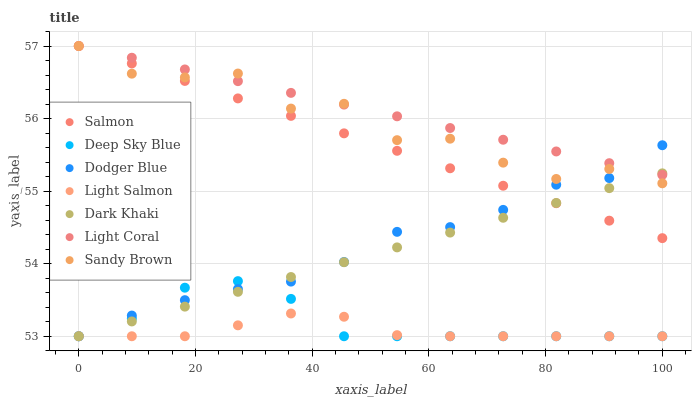Does Light Salmon have the minimum area under the curve?
Answer yes or no. Yes. Does Light Coral have the maximum area under the curve?
Answer yes or no. Yes. Does Salmon have the minimum area under the curve?
Answer yes or no. No. Does Salmon have the maximum area under the curve?
Answer yes or no. No. Is Salmon the smoothest?
Answer yes or no. Yes. Is Sandy Brown the roughest?
Answer yes or no. Yes. Is Light Salmon the smoothest?
Answer yes or no. No. Is Light Salmon the roughest?
Answer yes or no. No. Does Light Salmon have the lowest value?
Answer yes or no. Yes. Does Salmon have the lowest value?
Answer yes or no. No. Does Sandy Brown have the highest value?
Answer yes or no. Yes. Does Light Salmon have the highest value?
Answer yes or no. No. Is Deep Sky Blue less than Salmon?
Answer yes or no. Yes. Is Salmon greater than Deep Sky Blue?
Answer yes or no. Yes. Does Light Coral intersect Sandy Brown?
Answer yes or no. Yes. Is Light Coral less than Sandy Brown?
Answer yes or no. No. Is Light Coral greater than Sandy Brown?
Answer yes or no. No. Does Deep Sky Blue intersect Salmon?
Answer yes or no. No. 